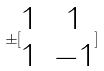<formula> <loc_0><loc_0><loc_500><loc_500>\pm [ \begin{matrix} 1 & 1 \\ 1 & - 1 \end{matrix} ]</formula> 